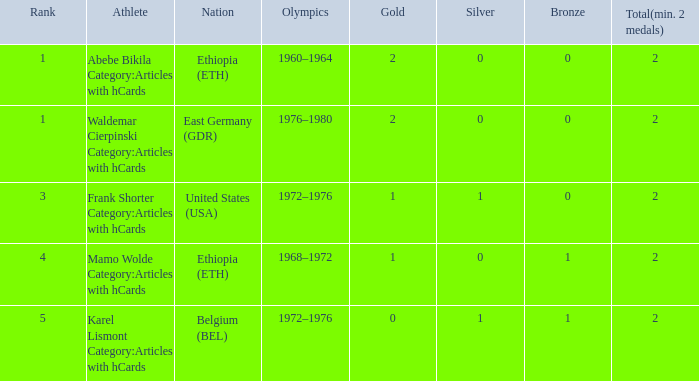What is the least amount of total medals won? 2.0. 